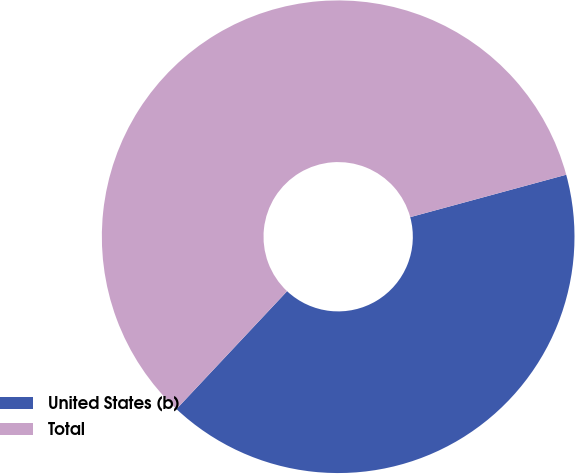<chart> <loc_0><loc_0><loc_500><loc_500><pie_chart><fcel>United States (b)<fcel>Total<nl><fcel>41.22%<fcel>58.78%<nl></chart> 